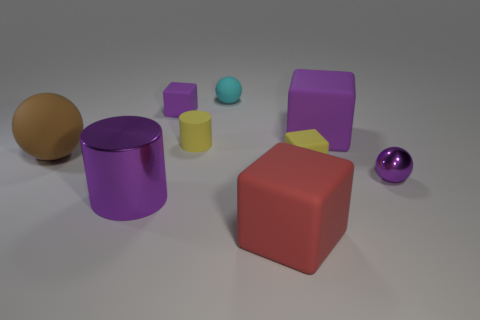What number of other objects are the same color as the shiny cylinder?
Make the answer very short. 3. Are there fewer big cylinders than gray things?
Ensure brevity in your answer.  No. There is a large metallic cylinder; is its color the same as the tiny cube behind the yellow cylinder?
Make the answer very short. Yes. Are there an equal number of tiny cyan objects behind the big shiny object and purple objects on the left side of the rubber cylinder?
Your response must be concise. No. How many matte objects have the same shape as the small purple metal thing?
Offer a terse response. 2. Are any tiny purple rubber blocks visible?
Keep it short and to the point. Yes. Is the material of the tiny yellow cylinder the same as the tiny purple thing in front of the small yellow cylinder?
Keep it short and to the point. No. There is a red cube that is the same size as the brown thing; what is its material?
Provide a succinct answer. Rubber. Is there a tiny green cube that has the same material as the big cylinder?
Keep it short and to the point. No. Is there a small ball to the left of the big purple thing behind the shiny object to the left of the cyan matte object?
Provide a short and direct response. Yes. 